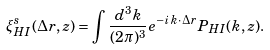<formula> <loc_0><loc_0><loc_500><loc_500>\xi ^ { s } _ { H I } ( { \Delta r } , z ) = \int \frac { d ^ { 3 } k } { ( 2 \pi ) ^ { 3 } } e ^ { - i \, k \cdot \, { \Delta r } } P _ { H I } ( { k } , z ) .</formula> 